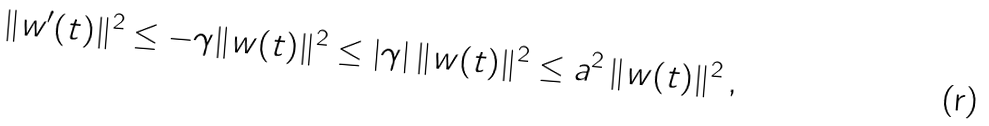Convert formula to latex. <formula><loc_0><loc_0><loc_500><loc_500>\| w ^ { \prime } ( t ) \| ^ { 2 } \leq - \gamma \| w ( t ) \| ^ { 2 } \leq | \gamma | \, \| w ( t ) \| ^ { 2 } \leq a ^ { 2 } \, \| w ( t ) \| ^ { 2 } \, ,</formula> 